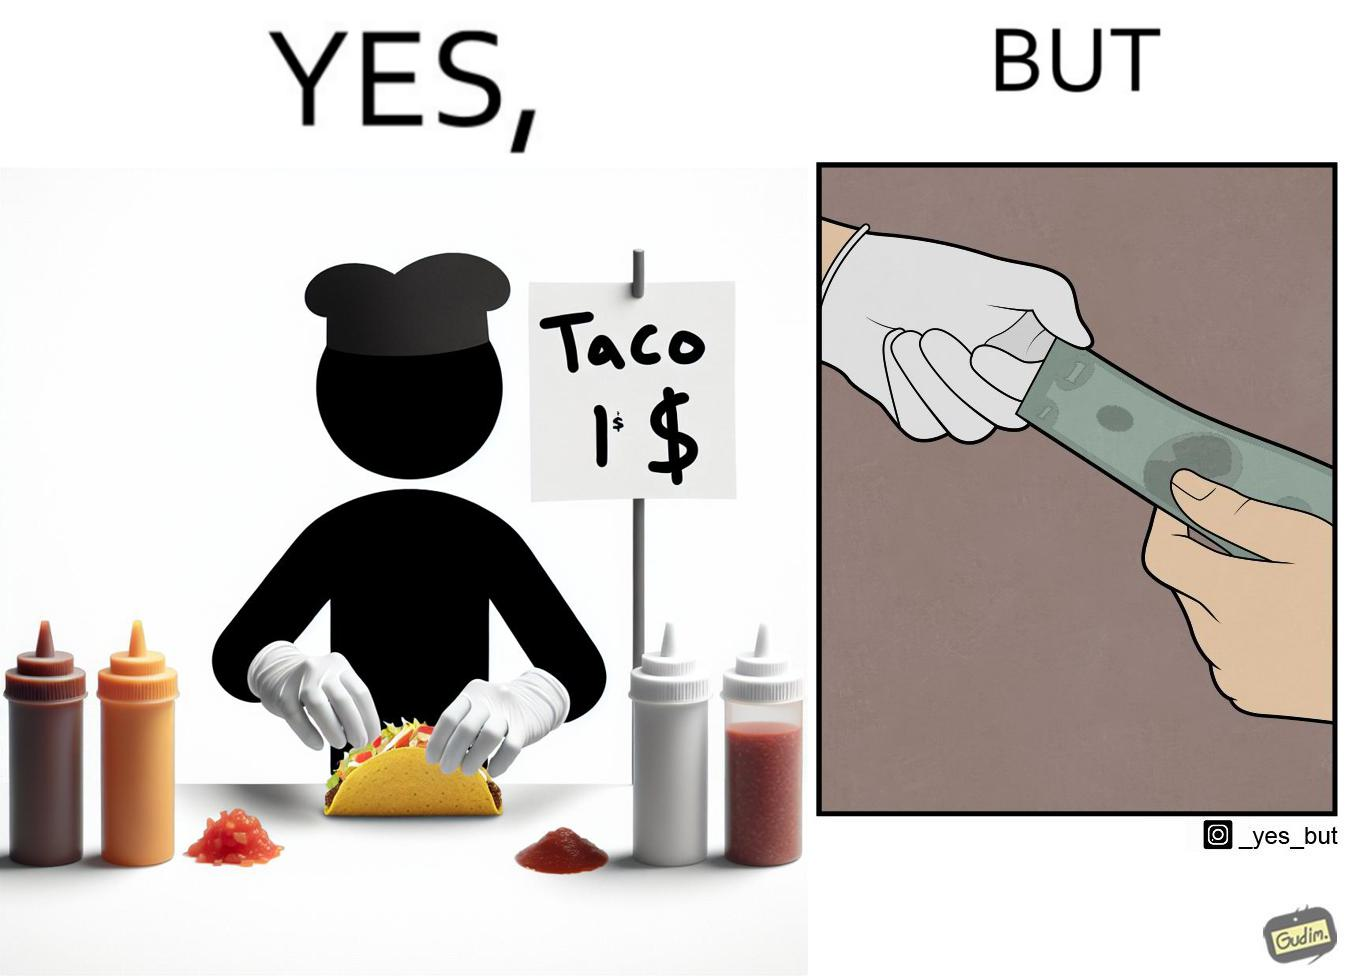Is this a satirical image? Yes, this image is satirical. 